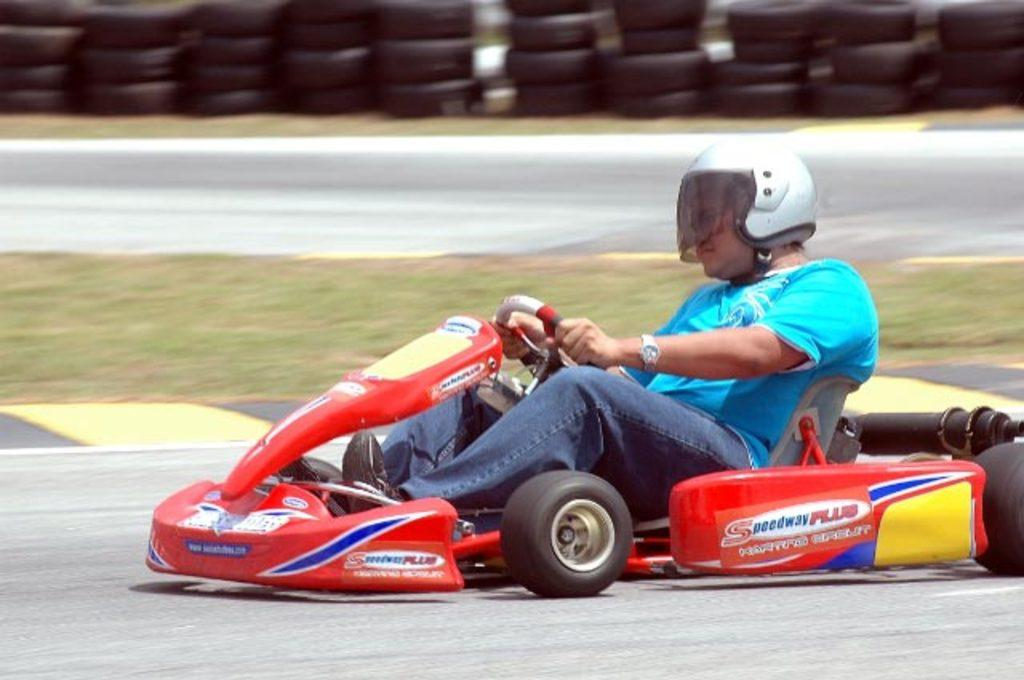Who is present in the image? There is a man in the image. What is the man wearing on his head? The man is wearing a helmet. What color is the man's shirt? The man is wearing a sky blue color shirt. What color are the man's jeans? The man is wearing blue color jeans. What is the man doing in the image? The man is riding a cart. What type of zinc is the man using to cry while washing the cart? There is no mention of zinc, crying, or washing in the image. The man is simply riding a cart while wearing a helmet, sky blue shirt, and blue jeans. 